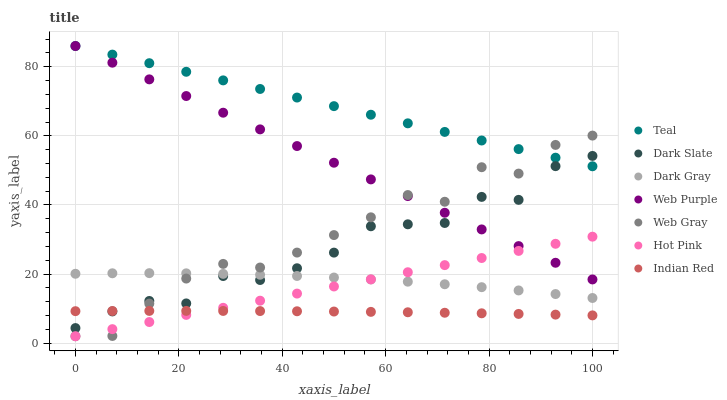Does Indian Red have the minimum area under the curve?
Answer yes or no. Yes. Does Teal have the maximum area under the curve?
Answer yes or no. Yes. Does Hot Pink have the minimum area under the curve?
Answer yes or no. No. Does Hot Pink have the maximum area under the curve?
Answer yes or no. No. Is Hot Pink the smoothest?
Answer yes or no. Yes. Is Web Gray the roughest?
Answer yes or no. Yes. Is Indian Red the smoothest?
Answer yes or no. No. Is Indian Red the roughest?
Answer yes or no. No. Does Web Gray have the lowest value?
Answer yes or no. Yes. Does Indian Red have the lowest value?
Answer yes or no. No. Does Teal have the highest value?
Answer yes or no. Yes. Does Hot Pink have the highest value?
Answer yes or no. No. Is Dark Gray less than Web Purple?
Answer yes or no. Yes. Is Teal greater than Hot Pink?
Answer yes or no. Yes. Does Hot Pink intersect Web Purple?
Answer yes or no. Yes. Is Hot Pink less than Web Purple?
Answer yes or no. No. Is Hot Pink greater than Web Purple?
Answer yes or no. No. Does Dark Gray intersect Web Purple?
Answer yes or no. No. 